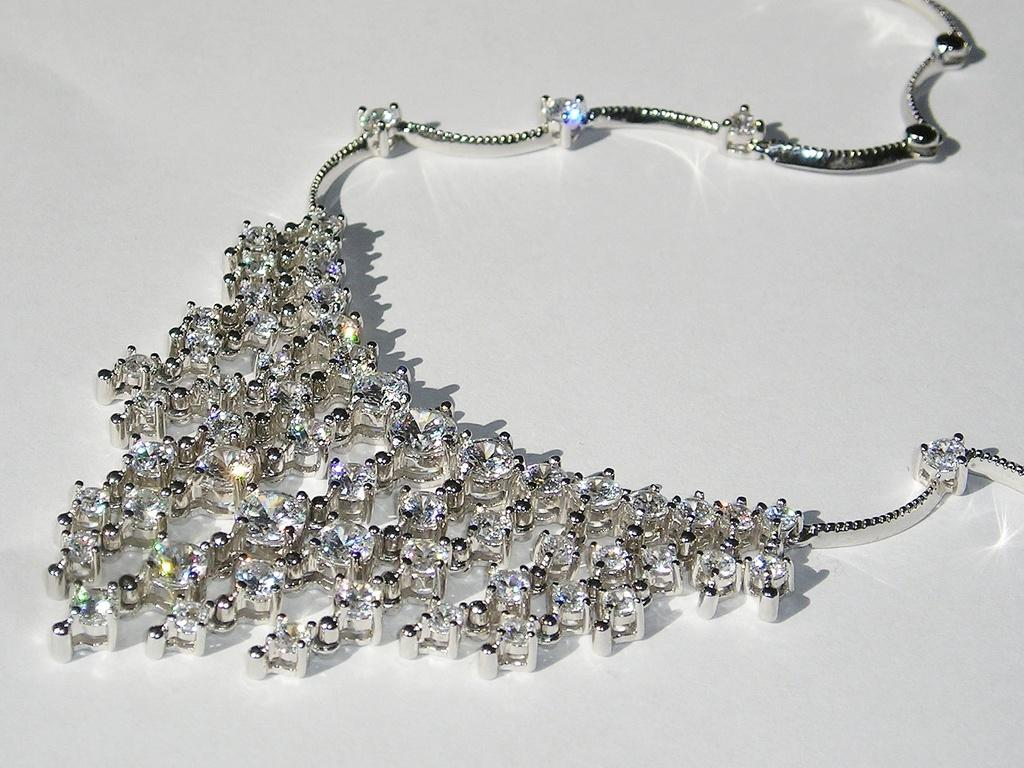What is the color of the surface in the image? The surface in the image is white. What object is placed on the white surface? There is a silver-colored necklace on the surface. What are the stones on the necklace like? The necklace has white stones. How does the nation contribute to the knot in the image? There is no nation or knot present in the image; it features a white surface with a silver-colored necklace that has white stones. 